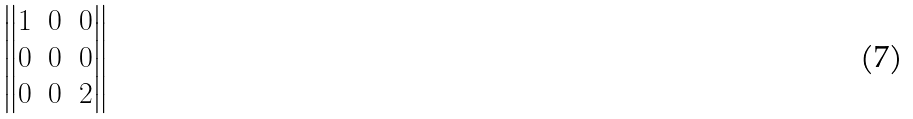<formula> <loc_0><loc_0><loc_500><loc_500>\begin{Vmatrix} 1 & 0 & 0 \\ 0 & 0 & 0 \\ 0 & 0 & 2 \end{Vmatrix}</formula> 